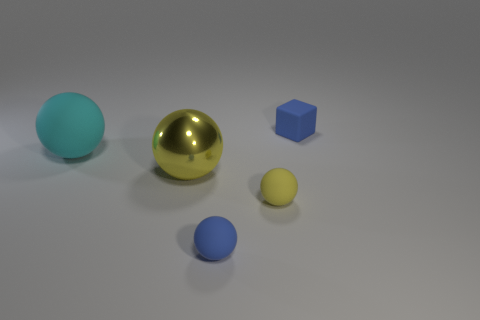What color is the other small object that is the same shape as the tiny yellow rubber thing?
Offer a very short reply. Blue. Are there more small blue matte objects that are in front of the tiny matte cube than tiny red metallic objects?
Make the answer very short. Yes. What color is the matte sphere that is to the left of the large yellow sphere?
Ensure brevity in your answer.  Cyan. Is the cyan rubber thing the same size as the yellow shiny ball?
Your response must be concise. Yes. How big is the blue ball?
Offer a terse response. Small. What is the shape of the small thing that is the same color as the matte cube?
Your response must be concise. Sphere. Are there more big yellow matte cylinders than blue rubber things?
Give a very brief answer. No. What is the color of the rubber object left of the tiny blue matte thing that is in front of the large object to the right of the big cyan rubber ball?
Offer a terse response. Cyan. There is a large object that is on the left side of the big yellow metal thing; does it have the same shape as the tiny yellow matte thing?
Your answer should be compact. Yes. There is a matte sphere that is the same size as the yellow matte object; what color is it?
Offer a very short reply. Blue. 